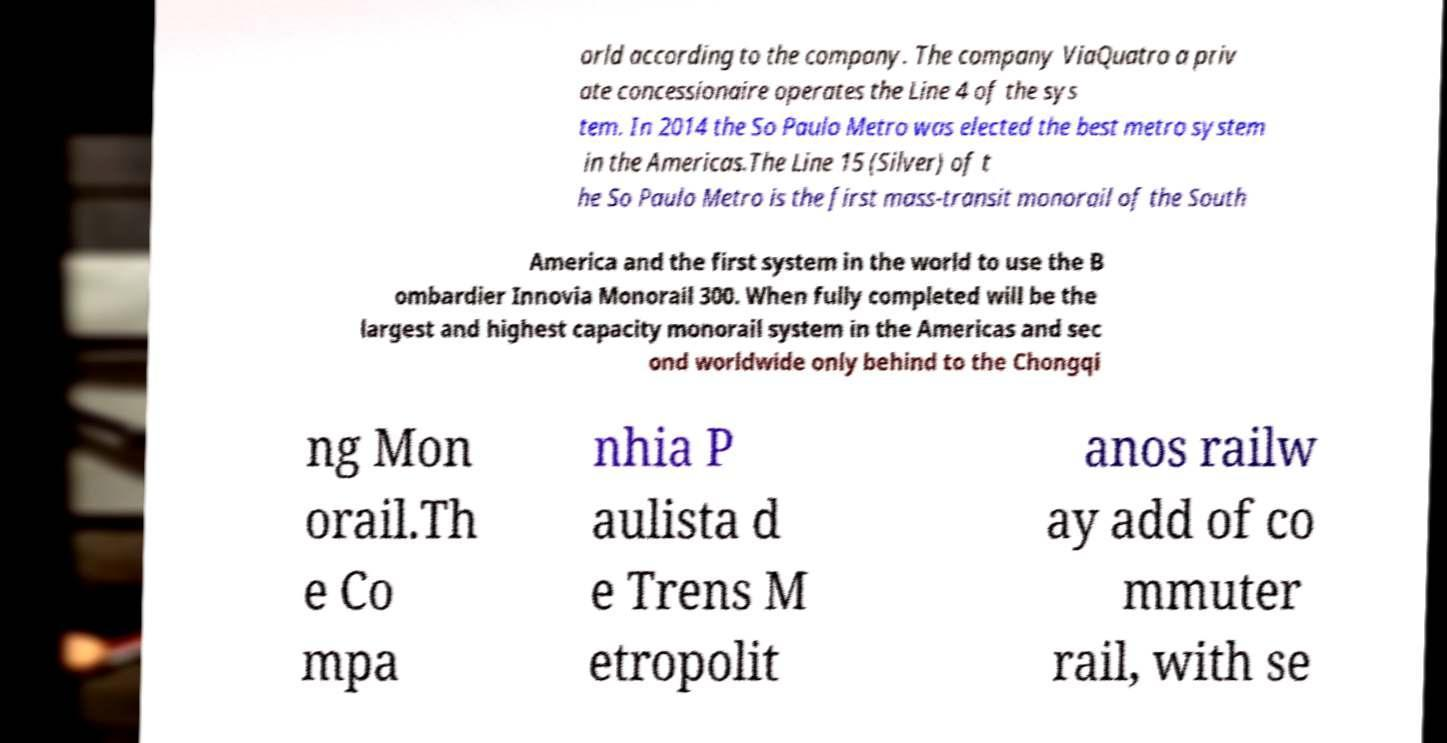Can you accurately transcribe the text from the provided image for me? orld according to the company. The company ViaQuatro a priv ate concessionaire operates the Line 4 of the sys tem. In 2014 the So Paulo Metro was elected the best metro system in the Americas.The Line 15 (Silver) of t he So Paulo Metro is the first mass-transit monorail of the South America and the first system in the world to use the B ombardier Innovia Monorail 300. When fully completed will be the largest and highest capacity monorail system in the Americas and sec ond worldwide only behind to the Chongqi ng Mon orail.Th e Co mpa nhia P aulista d e Trens M etropolit anos railw ay add of co mmuter rail, with se 